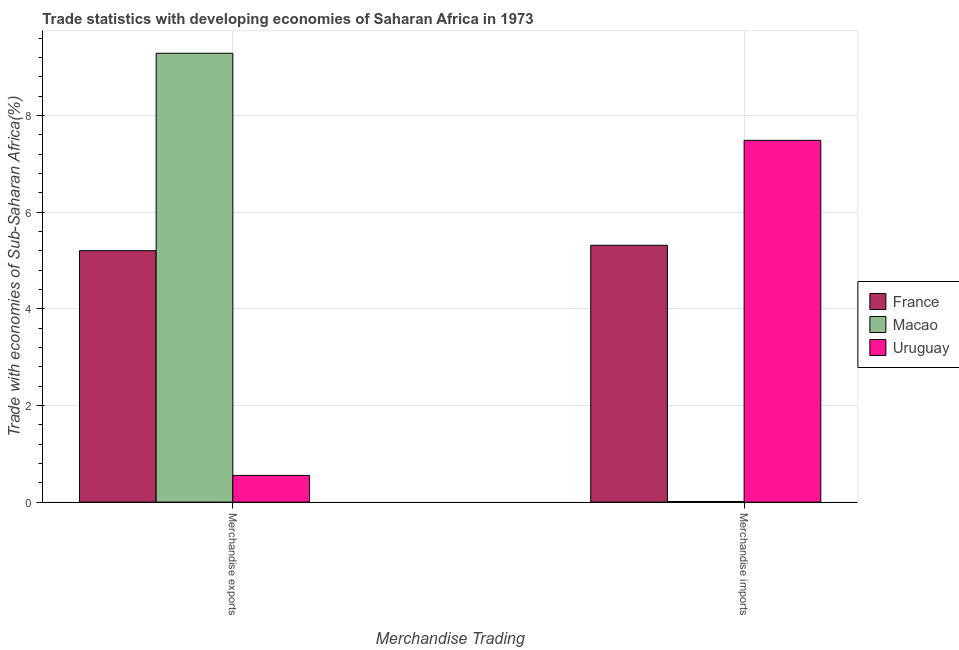How many different coloured bars are there?
Provide a short and direct response. 3. Are the number of bars on each tick of the X-axis equal?
Make the answer very short. Yes. What is the merchandise imports in France?
Give a very brief answer. 5.31. Across all countries, what is the maximum merchandise imports?
Offer a terse response. 7.49. Across all countries, what is the minimum merchandise imports?
Ensure brevity in your answer.  0.01. In which country was the merchandise imports maximum?
Keep it short and to the point. Uruguay. In which country was the merchandise exports minimum?
Keep it short and to the point. Uruguay. What is the total merchandise exports in the graph?
Offer a very short reply. 15.04. What is the difference between the merchandise imports in Macao and that in France?
Provide a short and direct response. -5.3. What is the difference between the merchandise imports in Uruguay and the merchandise exports in France?
Offer a terse response. 2.28. What is the average merchandise imports per country?
Your response must be concise. 4.27. What is the difference between the merchandise exports and merchandise imports in France?
Your answer should be compact. -0.11. In how many countries, is the merchandise imports greater than 4.8 %?
Your answer should be compact. 2. What is the ratio of the merchandise imports in Uruguay to that in Macao?
Ensure brevity in your answer.  559.27. In how many countries, is the merchandise imports greater than the average merchandise imports taken over all countries?
Your answer should be compact. 2. What does the 2nd bar from the left in Merchandise imports represents?
Keep it short and to the point. Macao. What does the 2nd bar from the right in Merchandise exports represents?
Give a very brief answer. Macao. How many bars are there?
Provide a short and direct response. 6. Are all the bars in the graph horizontal?
Keep it short and to the point. No. How many countries are there in the graph?
Give a very brief answer. 3. Are the values on the major ticks of Y-axis written in scientific E-notation?
Provide a short and direct response. No. Does the graph contain any zero values?
Offer a terse response. No. How are the legend labels stacked?
Provide a succinct answer. Vertical. What is the title of the graph?
Your response must be concise. Trade statistics with developing economies of Saharan Africa in 1973. What is the label or title of the X-axis?
Give a very brief answer. Merchandise Trading. What is the label or title of the Y-axis?
Your response must be concise. Trade with economies of Sub-Saharan Africa(%). What is the Trade with economies of Sub-Saharan Africa(%) of France in Merchandise exports?
Give a very brief answer. 5.2. What is the Trade with economies of Sub-Saharan Africa(%) of Macao in Merchandise exports?
Make the answer very short. 9.29. What is the Trade with economies of Sub-Saharan Africa(%) of Uruguay in Merchandise exports?
Ensure brevity in your answer.  0.55. What is the Trade with economies of Sub-Saharan Africa(%) in France in Merchandise imports?
Ensure brevity in your answer.  5.31. What is the Trade with economies of Sub-Saharan Africa(%) of Macao in Merchandise imports?
Offer a terse response. 0.01. What is the Trade with economies of Sub-Saharan Africa(%) of Uruguay in Merchandise imports?
Your response must be concise. 7.49. Across all Merchandise Trading, what is the maximum Trade with economies of Sub-Saharan Africa(%) in France?
Offer a very short reply. 5.31. Across all Merchandise Trading, what is the maximum Trade with economies of Sub-Saharan Africa(%) of Macao?
Provide a short and direct response. 9.29. Across all Merchandise Trading, what is the maximum Trade with economies of Sub-Saharan Africa(%) in Uruguay?
Give a very brief answer. 7.49. Across all Merchandise Trading, what is the minimum Trade with economies of Sub-Saharan Africa(%) of France?
Keep it short and to the point. 5.2. Across all Merchandise Trading, what is the minimum Trade with economies of Sub-Saharan Africa(%) in Macao?
Offer a terse response. 0.01. Across all Merchandise Trading, what is the minimum Trade with economies of Sub-Saharan Africa(%) in Uruguay?
Offer a terse response. 0.55. What is the total Trade with economies of Sub-Saharan Africa(%) of France in the graph?
Your answer should be compact. 10.52. What is the total Trade with economies of Sub-Saharan Africa(%) in Macao in the graph?
Provide a short and direct response. 9.3. What is the total Trade with economies of Sub-Saharan Africa(%) in Uruguay in the graph?
Offer a terse response. 8.04. What is the difference between the Trade with economies of Sub-Saharan Africa(%) of France in Merchandise exports and that in Merchandise imports?
Your response must be concise. -0.11. What is the difference between the Trade with economies of Sub-Saharan Africa(%) of Macao in Merchandise exports and that in Merchandise imports?
Offer a very short reply. 9.27. What is the difference between the Trade with economies of Sub-Saharan Africa(%) of Uruguay in Merchandise exports and that in Merchandise imports?
Your response must be concise. -6.93. What is the difference between the Trade with economies of Sub-Saharan Africa(%) in France in Merchandise exports and the Trade with economies of Sub-Saharan Africa(%) in Macao in Merchandise imports?
Your response must be concise. 5.19. What is the difference between the Trade with economies of Sub-Saharan Africa(%) of France in Merchandise exports and the Trade with economies of Sub-Saharan Africa(%) of Uruguay in Merchandise imports?
Keep it short and to the point. -2.28. What is the difference between the Trade with economies of Sub-Saharan Africa(%) of Macao in Merchandise exports and the Trade with economies of Sub-Saharan Africa(%) of Uruguay in Merchandise imports?
Provide a succinct answer. 1.8. What is the average Trade with economies of Sub-Saharan Africa(%) in France per Merchandise Trading?
Give a very brief answer. 5.26. What is the average Trade with economies of Sub-Saharan Africa(%) of Macao per Merchandise Trading?
Your answer should be compact. 4.65. What is the average Trade with economies of Sub-Saharan Africa(%) in Uruguay per Merchandise Trading?
Provide a succinct answer. 4.02. What is the difference between the Trade with economies of Sub-Saharan Africa(%) of France and Trade with economies of Sub-Saharan Africa(%) of Macao in Merchandise exports?
Make the answer very short. -4.09. What is the difference between the Trade with economies of Sub-Saharan Africa(%) of France and Trade with economies of Sub-Saharan Africa(%) of Uruguay in Merchandise exports?
Your response must be concise. 4.65. What is the difference between the Trade with economies of Sub-Saharan Africa(%) in Macao and Trade with economies of Sub-Saharan Africa(%) in Uruguay in Merchandise exports?
Offer a very short reply. 8.73. What is the difference between the Trade with economies of Sub-Saharan Africa(%) of France and Trade with economies of Sub-Saharan Africa(%) of Macao in Merchandise imports?
Provide a short and direct response. 5.3. What is the difference between the Trade with economies of Sub-Saharan Africa(%) in France and Trade with economies of Sub-Saharan Africa(%) in Uruguay in Merchandise imports?
Offer a very short reply. -2.17. What is the difference between the Trade with economies of Sub-Saharan Africa(%) in Macao and Trade with economies of Sub-Saharan Africa(%) in Uruguay in Merchandise imports?
Keep it short and to the point. -7.47. What is the ratio of the Trade with economies of Sub-Saharan Africa(%) in France in Merchandise exports to that in Merchandise imports?
Offer a very short reply. 0.98. What is the ratio of the Trade with economies of Sub-Saharan Africa(%) of Macao in Merchandise exports to that in Merchandise imports?
Keep it short and to the point. 693.86. What is the ratio of the Trade with economies of Sub-Saharan Africa(%) in Uruguay in Merchandise exports to that in Merchandise imports?
Give a very brief answer. 0.07. What is the difference between the highest and the second highest Trade with economies of Sub-Saharan Africa(%) in France?
Keep it short and to the point. 0.11. What is the difference between the highest and the second highest Trade with economies of Sub-Saharan Africa(%) of Macao?
Ensure brevity in your answer.  9.27. What is the difference between the highest and the second highest Trade with economies of Sub-Saharan Africa(%) in Uruguay?
Offer a terse response. 6.93. What is the difference between the highest and the lowest Trade with economies of Sub-Saharan Africa(%) in France?
Your answer should be very brief. 0.11. What is the difference between the highest and the lowest Trade with economies of Sub-Saharan Africa(%) in Macao?
Your answer should be very brief. 9.27. What is the difference between the highest and the lowest Trade with economies of Sub-Saharan Africa(%) in Uruguay?
Offer a very short reply. 6.93. 